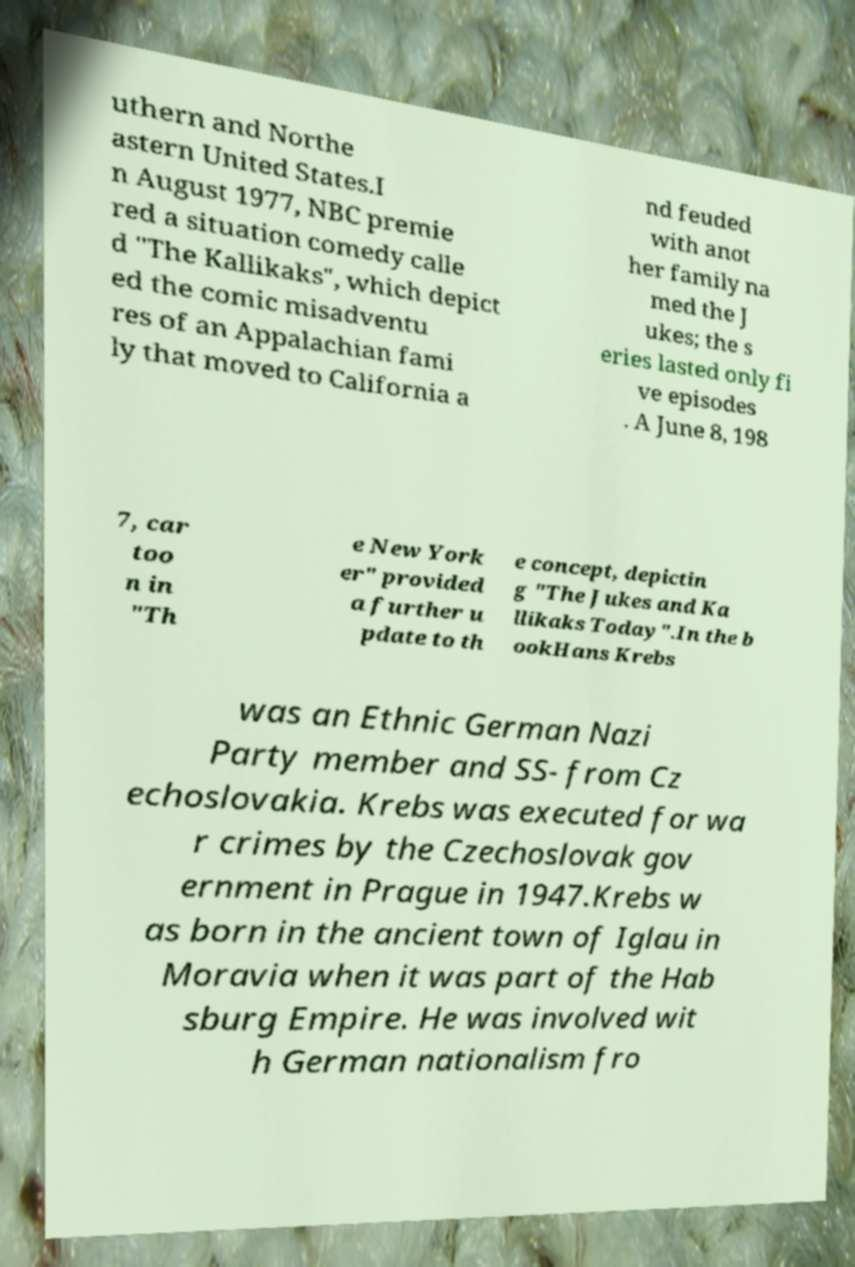Can you read and provide the text displayed in the image?This photo seems to have some interesting text. Can you extract and type it out for me? uthern and Northe astern United States.I n August 1977, NBC premie red a situation comedy calle d "The Kallikaks", which depict ed the comic misadventu res of an Appalachian fami ly that moved to California a nd feuded with anot her family na med the J ukes; the s eries lasted only fi ve episodes . A June 8, 198 7, car too n in "Th e New York er" provided a further u pdate to th e concept, depictin g "The Jukes and Ka llikaks Today".In the b ookHans Krebs was an Ethnic German Nazi Party member and SS- from Cz echoslovakia. Krebs was executed for wa r crimes by the Czechoslovak gov ernment in Prague in 1947.Krebs w as born in the ancient town of Iglau in Moravia when it was part of the Hab sburg Empire. He was involved wit h German nationalism fro 